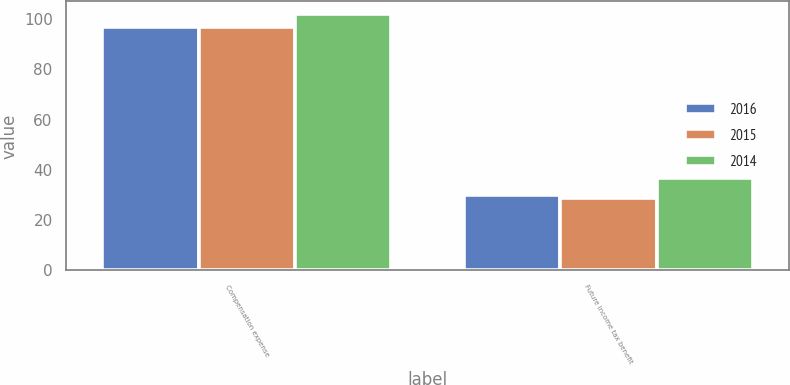<chart> <loc_0><loc_0><loc_500><loc_500><stacked_bar_chart><ecel><fcel>Compensation expense<fcel>Future income tax benefit<nl><fcel>2016<fcel>97<fcel>30<nl><fcel>2015<fcel>97<fcel>29<nl><fcel>2014<fcel>102<fcel>37<nl></chart> 